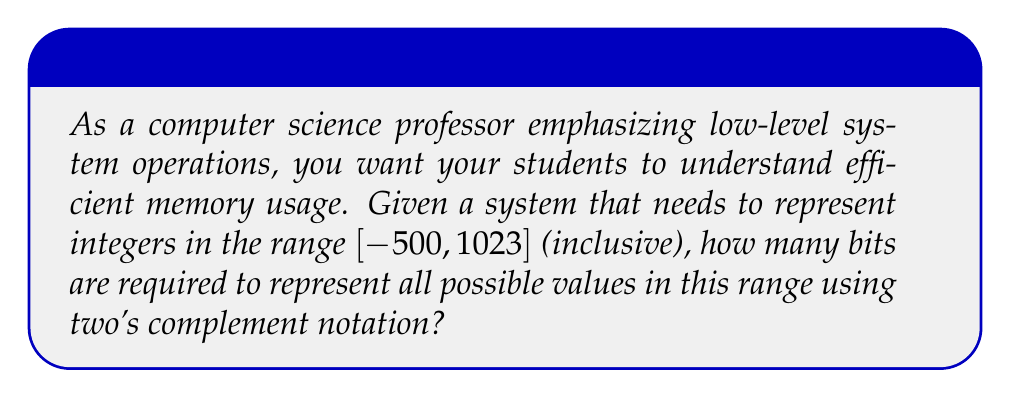Give your solution to this math problem. To determine the number of bits required, we need to follow these steps:

1) First, calculate the total number of integers in the given range:
   $1023 - (-500) + 1 = 1524$ integers

2) In two's complement notation, the most significant bit represents the sign (0 for positive, 1 for negative). The range of values that can be represented with $n$ bits in two's complement is $[-2^{n-1}, 2^{n-1} - 1]$.

3) We need to find the smallest $n$ such that:
   $-2^{n-1} \leq -500$ and $2^{n-1} - 1 \geq 1023$

4) Let's solve the second inequality:
   $2^{n-1} - 1 \geq 1023$
   $2^{n-1} \geq 1024$
   $n-1 \geq \log_2(1024) = 10$
   $n \geq 11$

5) We can verify that this also satisfies the first inequality:
   $-2^{11-1} = -2^{10} = -1024 \leq -500$

6) Therefore, the smallest number of bits that can represent this range is 11.

This problem demonstrates the importance of understanding binary representations and efficient memory usage in low-level system operations, which is crucial for developing optimized software and contributing meaningfully to open-source projects.
Answer: 11 bits 